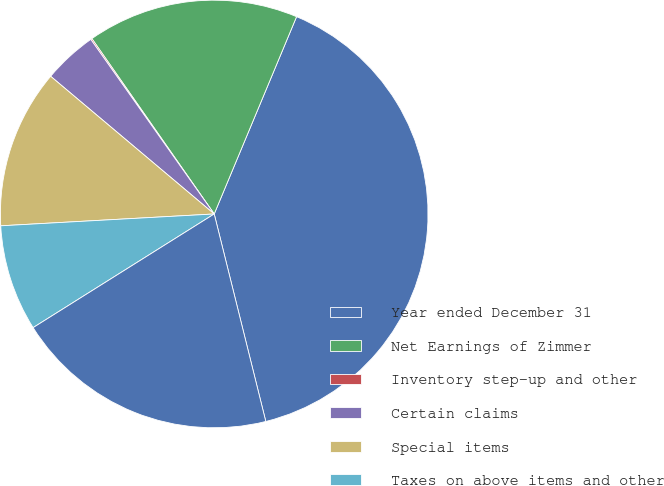Convert chart. <chart><loc_0><loc_0><loc_500><loc_500><pie_chart><fcel>Year ended December 31<fcel>Net Earnings of Zimmer<fcel>Inventory step-up and other<fcel>Certain claims<fcel>Special items<fcel>Taxes on above items and other<fcel>Adjusted Net Earnings<nl><fcel>39.83%<fcel>15.99%<fcel>0.1%<fcel>4.07%<fcel>12.02%<fcel>8.04%<fcel>19.96%<nl></chart> 